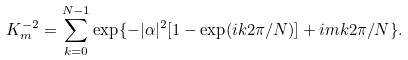Convert formula to latex. <formula><loc_0><loc_0><loc_500><loc_500>K _ { m } ^ { - 2 } = \sum _ { k = 0 } ^ { N - 1 } \exp \{ - | \alpha | ^ { 2 } [ 1 - \exp ( i k 2 \pi / N ) ] + i m k 2 \pi / N \} .</formula> 